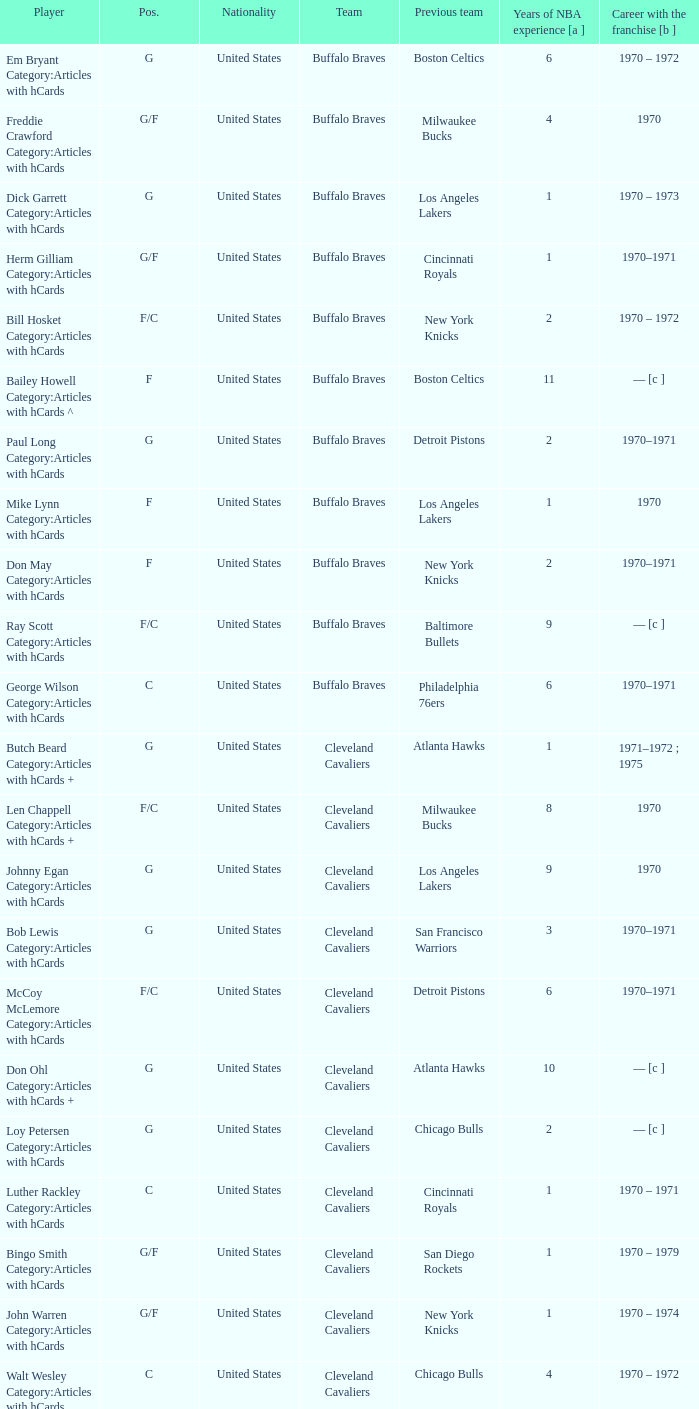What is the number of years the portland trail blazers' player in the guard position has spent in the nba? 2.0. 